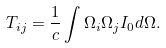Convert formula to latex. <formula><loc_0><loc_0><loc_500><loc_500>T _ { i j } = \frac { 1 } { c } \int { \Omega } _ { i } { \Omega } _ { j } I _ { 0 } d \Omega .</formula> 